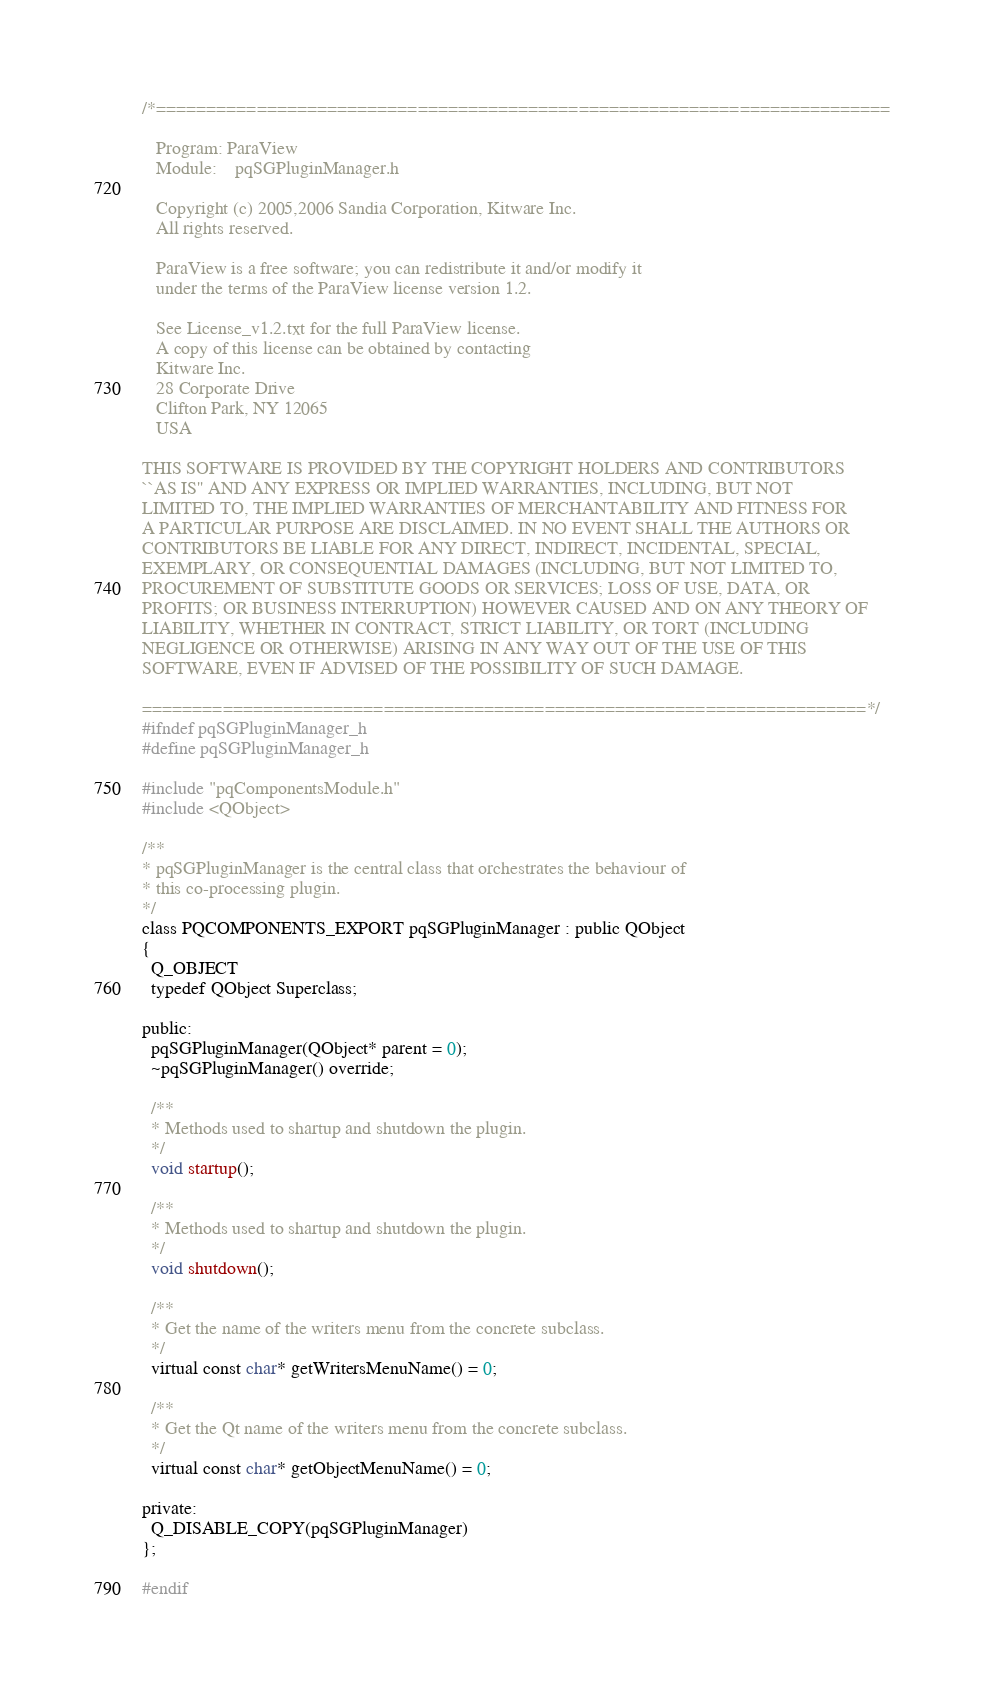<code> <loc_0><loc_0><loc_500><loc_500><_C_>/*=========================================================================

   Program: ParaView
   Module:    pqSGPluginManager.h

   Copyright (c) 2005,2006 Sandia Corporation, Kitware Inc.
   All rights reserved.

   ParaView is a free software; you can redistribute it and/or modify it
   under the terms of the ParaView license version 1.2.

   See License_v1.2.txt for the full ParaView license.
   A copy of this license can be obtained by contacting
   Kitware Inc.
   28 Corporate Drive
   Clifton Park, NY 12065
   USA

THIS SOFTWARE IS PROVIDED BY THE COPYRIGHT HOLDERS AND CONTRIBUTORS
``AS IS'' AND ANY EXPRESS OR IMPLIED WARRANTIES, INCLUDING, BUT NOT
LIMITED TO, THE IMPLIED WARRANTIES OF MERCHANTABILITY AND FITNESS FOR
A PARTICULAR PURPOSE ARE DISCLAIMED. IN NO EVENT SHALL THE AUTHORS OR
CONTRIBUTORS BE LIABLE FOR ANY DIRECT, INDIRECT, INCIDENTAL, SPECIAL,
EXEMPLARY, OR CONSEQUENTIAL DAMAGES (INCLUDING, BUT NOT LIMITED TO,
PROCUREMENT OF SUBSTITUTE GOODS OR SERVICES; LOSS OF USE, DATA, OR
PROFITS; OR BUSINESS INTERRUPTION) HOWEVER CAUSED AND ON ANY THEORY OF
LIABILITY, WHETHER IN CONTRACT, STRICT LIABILITY, OR TORT (INCLUDING
NEGLIGENCE OR OTHERWISE) ARISING IN ANY WAY OUT OF THE USE OF THIS
SOFTWARE, EVEN IF ADVISED OF THE POSSIBILITY OF SUCH DAMAGE.

========================================================================*/
#ifndef pqSGPluginManager_h
#define pqSGPluginManager_h

#include "pqComponentsModule.h"
#include <QObject>

/**
* pqSGPluginManager is the central class that orchestrates the behaviour of
* this co-processing plugin.
*/
class PQCOMPONENTS_EXPORT pqSGPluginManager : public QObject
{
  Q_OBJECT
  typedef QObject Superclass;

public:
  pqSGPluginManager(QObject* parent = 0);
  ~pqSGPluginManager() override;

  /**
  * Methods used to shartup and shutdown the plugin.
  */
  void startup();

  /**
  * Methods used to shartup and shutdown the plugin.
  */
  void shutdown();

  /**
  * Get the name of the writers menu from the concrete subclass.
  */
  virtual const char* getWritersMenuName() = 0;

  /**
  * Get the Qt name of the writers menu from the concrete subclass.
  */
  virtual const char* getObjectMenuName() = 0;

private:
  Q_DISABLE_COPY(pqSGPluginManager)
};

#endif
</code> 